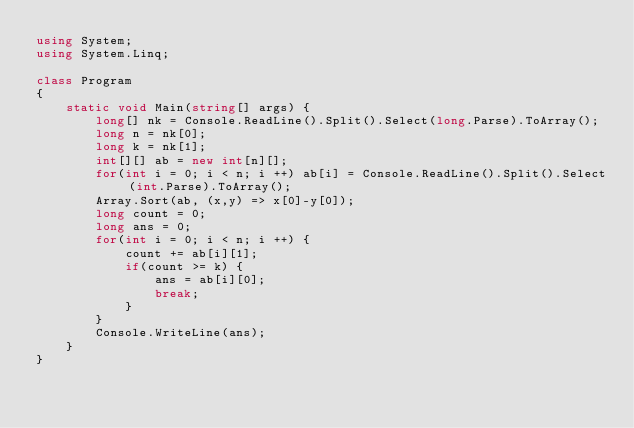Convert code to text. <code><loc_0><loc_0><loc_500><loc_500><_C#_>using System;
using System.Linq;

class Program
{
    static void Main(string[] args) {
        long[] nk = Console.ReadLine().Split().Select(long.Parse).ToArray();
        long n = nk[0];
        long k = nk[1];
        int[][] ab = new int[n][];
        for(int i = 0; i < n; i ++) ab[i] = Console.ReadLine().Split().Select(int.Parse).ToArray();
        Array.Sort(ab, (x,y) => x[0]-y[0]);
        long count = 0;
        long ans = 0;
        for(int i = 0; i < n; i ++) {
            count += ab[i][1];
            if(count >= k) {
                ans = ab[i][0];
                break;
            }
        }
        Console.WriteLine(ans);
    }
}
</code> 